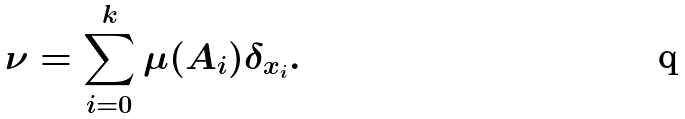<formula> <loc_0><loc_0><loc_500><loc_500>\nu = \sum _ { i = 0 } ^ { k } \mu ( A _ { i } ) \delta _ { x _ { i } } .</formula> 